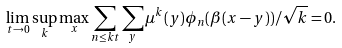<formula> <loc_0><loc_0><loc_500><loc_500>\lim _ { t \to 0 } \sup _ { k } \max _ { x } \sum _ { n \leq k t } \sum _ { y } \mu ^ { k } ( y ) \phi _ { n } ( \beta ( x - y ) ) / \sqrt { k } = 0 .</formula> 